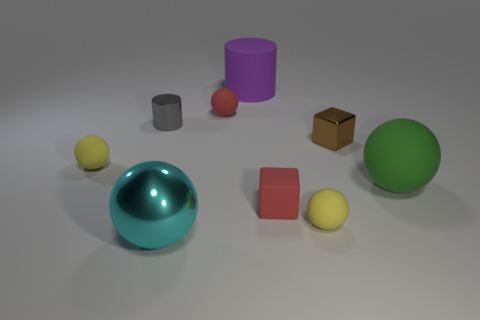Subtract all cyan cylinders. How many yellow spheres are left? 2 Subtract all cyan metal balls. How many balls are left? 4 Subtract all cyan spheres. How many spheres are left? 4 Add 1 shiny cubes. How many objects exist? 10 Subtract 1 blocks. How many blocks are left? 1 Subtract all blocks. How many objects are left? 7 Subtract all green spheres. Subtract all gray blocks. How many spheres are left? 4 Add 1 tiny brown metallic cubes. How many tiny brown metallic cubes are left? 2 Add 6 large purple objects. How many large purple objects exist? 7 Subtract 0 brown spheres. How many objects are left? 9 